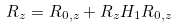Convert formula to latex. <formula><loc_0><loc_0><loc_500><loc_500>R _ { z } = R _ { 0 , z } + R _ { z } H _ { 1 } R _ { 0 , z }</formula> 